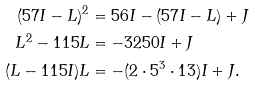Convert formula to latex. <formula><loc_0><loc_0><loc_500><loc_500>( 5 7 I - L ) ^ { 2 } & = 5 6 I - ( 5 7 I - L ) + J \\ L ^ { 2 } - 1 1 5 L & = - 3 2 5 0 I + J \\ ( L - 1 1 5 I ) L & = - ( 2 \cdot 5 ^ { 3 } \cdot 1 3 ) I + J .</formula> 